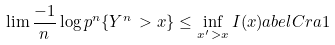<formula> <loc_0><loc_0><loc_500><loc_500>\lim \frac { - 1 } { n } \log p ^ { n } \{ Y ^ { n } \, > x \} \leq \inf _ { x ^ { \prime } \, > x } I ( x ) \L a b e l { C r a 1 }</formula> 